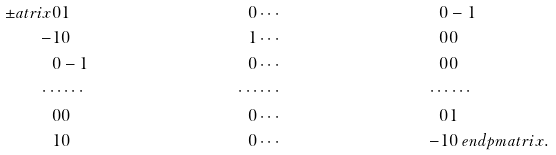Convert formula to latex. <formula><loc_0><loc_0><loc_500><loc_500>\pm a t r i x 0 & 1 & 0 & \cdots & 0 & - 1 \\ - 1 & 0 & 1 & \cdots & 0 & 0 \\ 0 & - 1 & 0 & \cdots & 0 & 0 \\ \cdots & \cdots & \cdots & \cdots & \cdots & \cdots \\ 0 & 0 & 0 & \cdots & 0 & 1 \\ 1 & 0 & 0 & \cdots & - 1 & 0 \ e n d p m a t r i x .</formula> 